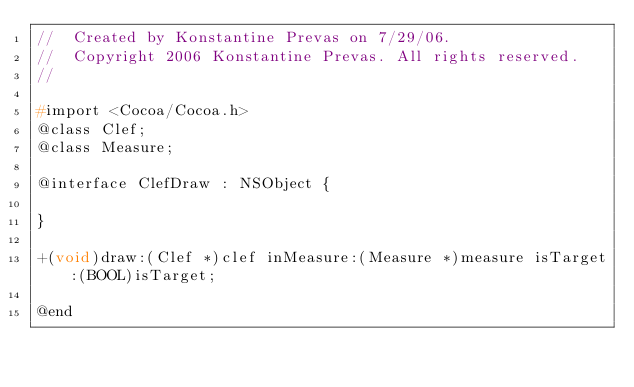<code> <loc_0><loc_0><loc_500><loc_500><_C_>//  Created by Konstantine Prevas on 7/29/06.
//  Copyright 2006 Konstantine Prevas. All rights reserved.
//

#import <Cocoa/Cocoa.h>
@class Clef;
@class Measure;

@interface ClefDraw : NSObject {

}

+(void)draw:(Clef *)clef inMeasure:(Measure *)measure isTarget:(BOOL)isTarget;

@end
</code> 